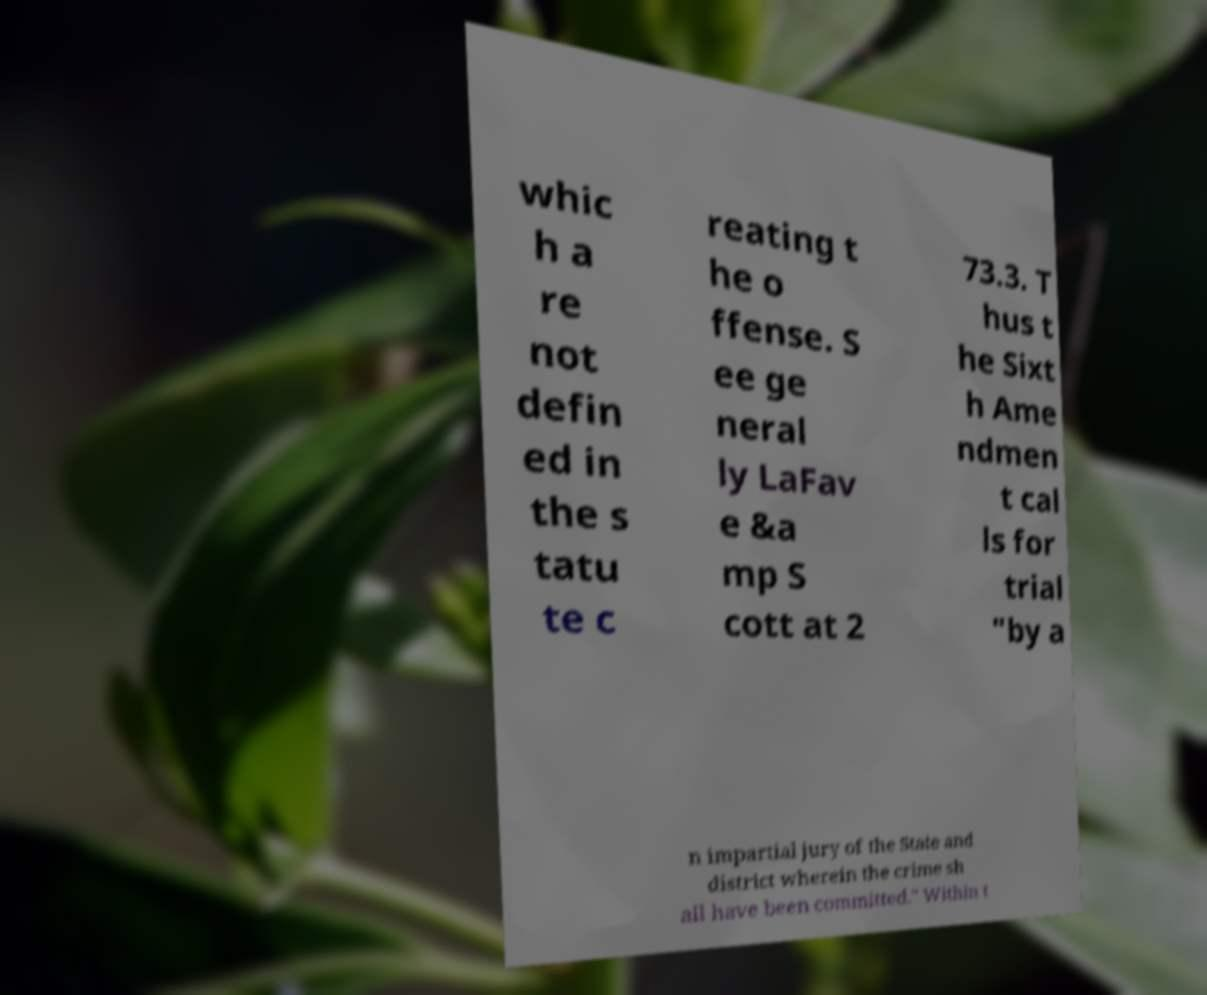Can you read and provide the text displayed in the image?This photo seems to have some interesting text. Can you extract and type it out for me? whic h a re not defin ed in the s tatu te c reating t he o ffense. S ee ge neral ly LaFav e &a mp S cott at 2 73.3. T hus t he Sixt h Ame ndmen t cal ls for trial "by a n impartial jury of the State and district wherein the crime sh all have been committed." Within t 